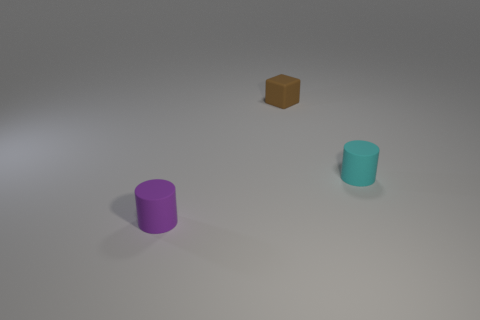There is a brown object; is it the same shape as the rubber object to the left of the small brown block?
Provide a short and direct response. No. Is there a cyan object that has the same material as the purple object?
Offer a terse response. Yes. Are there any small purple cylinders that are in front of the cylinder that is in front of the thing that is on the right side of the tiny brown rubber object?
Make the answer very short. No. How many other things are the same shape as the tiny purple matte thing?
Your answer should be very brief. 1. What color is the small rubber object that is in front of the small cyan rubber object behind the small rubber object that is to the left of the block?
Offer a very short reply. Purple. What number of brown rubber things are there?
Make the answer very short. 1. What number of large things are red shiny cylinders or brown matte objects?
Your response must be concise. 0. What shape is the purple rubber thing that is the same size as the brown thing?
Provide a succinct answer. Cylinder. What is the material of the cylinder behind the matte cylinder that is in front of the small cyan thing?
Offer a very short reply. Rubber. What number of objects are either small objects that are in front of the tiny cube or small rubber blocks?
Make the answer very short. 3. 